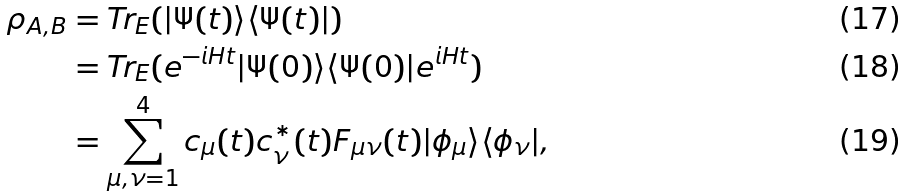<formula> <loc_0><loc_0><loc_500><loc_500>\rho _ { A , B } & = \text {Tr} _ { E } ( | \Psi ( t ) \rangle \langle \Psi ( t ) | ) \\ & = \text {Tr} _ { E } ( e ^ { - i H t } | \Psi ( 0 ) \rangle \langle \Psi ( 0 ) | e ^ { i H t } ) \\ & = \sum _ { \mu , \nu = 1 } ^ { 4 } c _ { \mu } ( t ) c _ { \nu } ^ { \ast } ( t ) F _ { \mu \nu } ( t ) | \phi _ { \mu } \rangle \langle \phi _ { \nu } | ,</formula> 